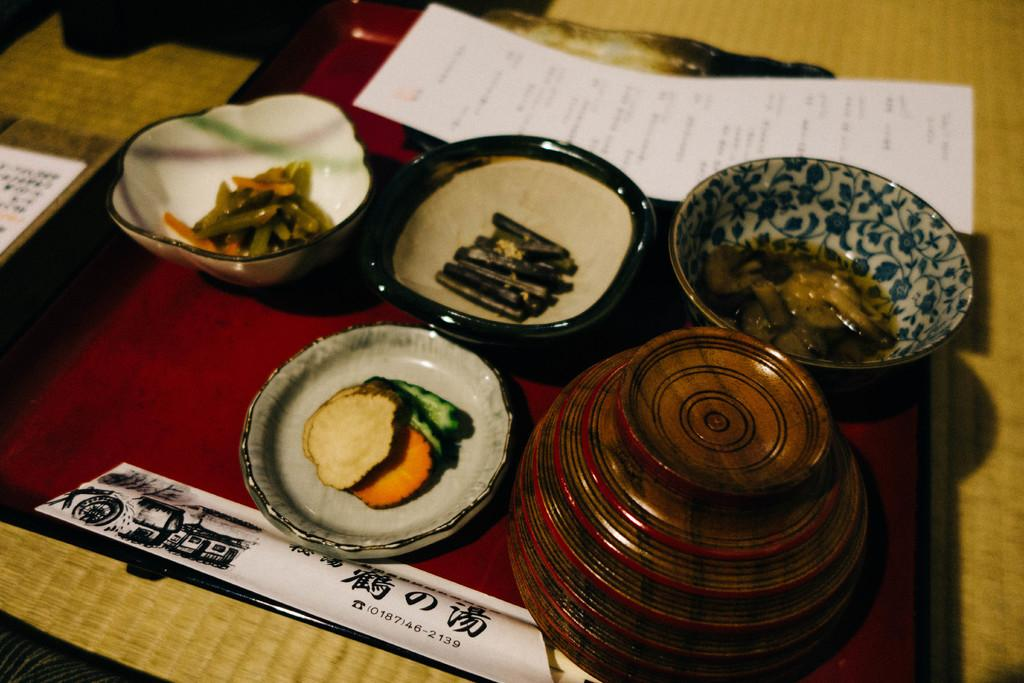What can be found in the bowls in the image? There are food items in the bowls in the image. Where are the bowls located? The bowls are on a surface in the image. What is visible at the top of the image? There is a white color paper at the top of the image. What theory is being discussed in the image? There is no discussion or theory present in the image; it features bowls with food items and a white color paper. Can you see any cemetery in the image? There is no cemetery present in the image. 